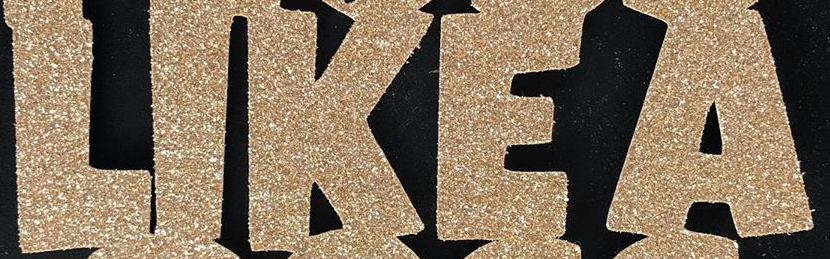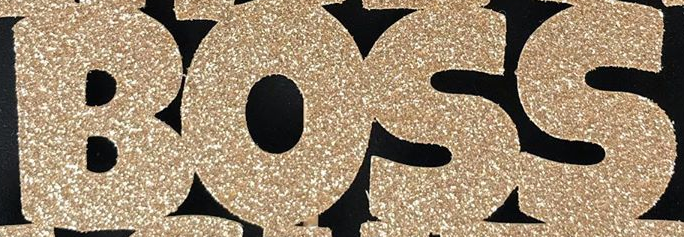What text is displayed in these images sequentially, separated by a semicolon? LIKEA; BOSS 